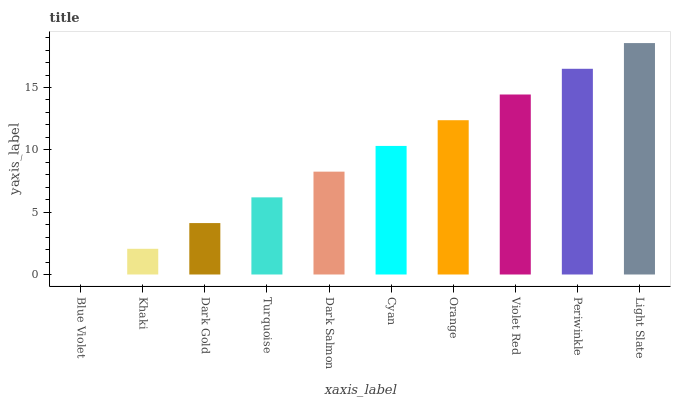Is Khaki the minimum?
Answer yes or no. No. Is Khaki the maximum?
Answer yes or no. No. Is Khaki greater than Blue Violet?
Answer yes or no. Yes. Is Blue Violet less than Khaki?
Answer yes or no. Yes. Is Blue Violet greater than Khaki?
Answer yes or no. No. Is Khaki less than Blue Violet?
Answer yes or no. No. Is Cyan the high median?
Answer yes or no. Yes. Is Dark Salmon the low median?
Answer yes or no. Yes. Is Light Slate the high median?
Answer yes or no. No. Is Periwinkle the low median?
Answer yes or no. No. 